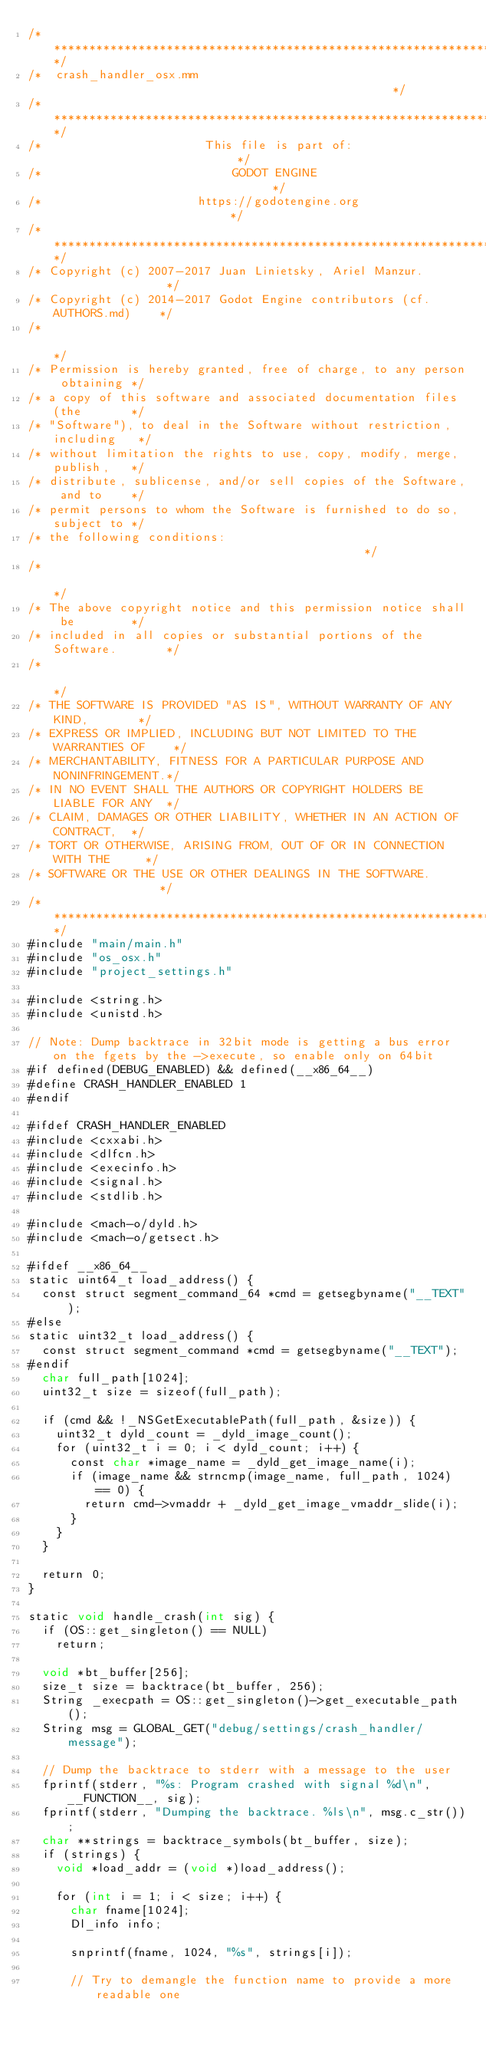Convert code to text. <code><loc_0><loc_0><loc_500><loc_500><_ObjectiveC_>/*************************************************************************/
/*  crash_handler_osx.mm                                                 */
/*************************************************************************/
/*                       This file is part of:                           */
/*                           GODOT ENGINE                                */
/*                      https://godotengine.org                          */
/*************************************************************************/
/* Copyright (c) 2007-2017 Juan Linietsky, Ariel Manzur.                 */
/* Copyright (c) 2014-2017 Godot Engine contributors (cf. AUTHORS.md)    */
/*                                                                       */
/* Permission is hereby granted, free of charge, to any person obtaining */
/* a copy of this software and associated documentation files (the       */
/* "Software"), to deal in the Software without restriction, including   */
/* without limitation the rights to use, copy, modify, merge, publish,   */
/* distribute, sublicense, and/or sell copies of the Software, and to    */
/* permit persons to whom the Software is furnished to do so, subject to */
/* the following conditions:                                             */
/*                                                                       */
/* The above copyright notice and this permission notice shall be        */
/* included in all copies or substantial portions of the Software.       */
/*                                                                       */
/* THE SOFTWARE IS PROVIDED "AS IS", WITHOUT WARRANTY OF ANY KIND,       */
/* EXPRESS OR IMPLIED, INCLUDING BUT NOT LIMITED TO THE WARRANTIES OF    */
/* MERCHANTABILITY, FITNESS FOR A PARTICULAR PURPOSE AND NONINFRINGEMENT.*/
/* IN NO EVENT SHALL THE AUTHORS OR COPYRIGHT HOLDERS BE LIABLE FOR ANY  */
/* CLAIM, DAMAGES OR OTHER LIABILITY, WHETHER IN AN ACTION OF CONTRACT,  */
/* TORT OR OTHERWISE, ARISING FROM, OUT OF OR IN CONNECTION WITH THE     */
/* SOFTWARE OR THE USE OR OTHER DEALINGS IN THE SOFTWARE.                */
/*************************************************************************/
#include "main/main.h"
#include "os_osx.h"
#include "project_settings.h"

#include <string.h>
#include <unistd.h>

// Note: Dump backtrace in 32bit mode is getting a bus error on the fgets by the ->execute, so enable only on 64bit
#if defined(DEBUG_ENABLED) && defined(__x86_64__)
#define CRASH_HANDLER_ENABLED 1
#endif

#ifdef CRASH_HANDLER_ENABLED
#include <cxxabi.h>
#include <dlfcn.h>
#include <execinfo.h>
#include <signal.h>
#include <stdlib.h>

#include <mach-o/dyld.h>
#include <mach-o/getsect.h>

#ifdef __x86_64__
static uint64_t load_address() {
	const struct segment_command_64 *cmd = getsegbyname("__TEXT");
#else
static uint32_t load_address() {
	const struct segment_command *cmd = getsegbyname("__TEXT");
#endif
	char full_path[1024];
	uint32_t size = sizeof(full_path);

	if (cmd && !_NSGetExecutablePath(full_path, &size)) {
		uint32_t dyld_count = _dyld_image_count();
		for (uint32_t i = 0; i < dyld_count; i++) {
			const char *image_name = _dyld_get_image_name(i);
			if (image_name && strncmp(image_name, full_path, 1024) == 0) {
				return cmd->vmaddr + _dyld_get_image_vmaddr_slide(i);
			}
		}
	}

	return 0;
}

static void handle_crash(int sig) {
	if (OS::get_singleton() == NULL)
		return;

	void *bt_buffer[256];
	size_t size = backtrace(bt_buffer, 256);
	String _execpath = OS::get_singleton()->get_executable_path();
	String msg = GLOBAL_GET("debug/settings/crash_handler/message");

	// Dump the backtrace to stderr with a message to the user
	fprintf(stderr, "%s: Program crashed with signal %d\n", __FUNCTION__, sig);
	fprintf(stderr, "Dumping the backtrace. %ls\n", msg.c_str());
	char **strings = backtrace_symbols(bt_buffer, size);
	if (strings) {
		void *load_addr = (void *)load_address();

		for (int i = 1; i < size; i++) {
			char fname[1024];
			Dl_info info;

			snprintf(fname, 1024, "%s", strings[i]);

			// Try to demangle the function name to provide a more readable one</code> 